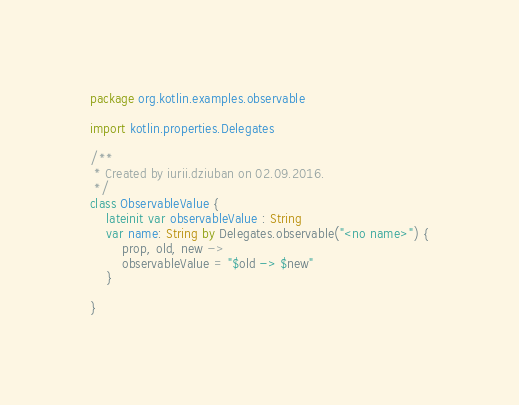Convert code to text. <code><loc_0><loc_0><loc_500><loc_500><_Kotlin_>package org.kotlin.examples.observable

import kotlin.properties.Delegates

/**
 * Created by iurii.dziuban on 02.09.2016.
 */
class ObservableValue {
    lateinit var observableValue : String
    var name: String by Delegates.observable("<no name>") {
        prop, old, new ->
        observableValue = "$old -> $new"
    }

}</code> 